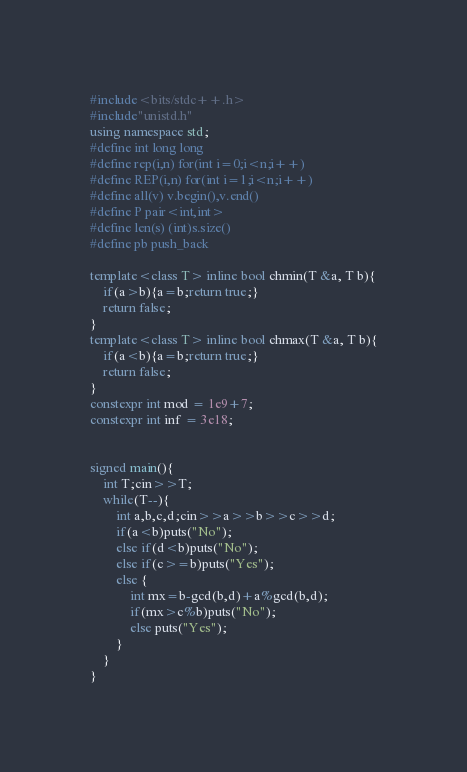Convert code to text. <code><loc_0><loc_0><loc_500><loc_500><_C++_>#include<bits/stdc++.h>
#include"unistd.h"
using namespace std;
#define int long long
#define rep(i,n) for(int i=0;i<n;i++)
#define REP(i,n) for(int i=1;i<n;i++)
#define all(v) v.begin(),v.end()
#define P pair<int,int>
#define len(s) (int)s.size()
#define pb push_back

template<class T> inline bool chmin(T &a, T b){
	if(a>b){a=b;return true;}
	return false;
}
template<class T> inline bool chmax(T &a, T b){
	if(a<b){a=b;return true;}
	return false;
}
constexpr int mod = 1e9+7;
constexpr int inf = 3e18;


signed main(){
	int T;cin>>T;
	while(T--){
		int a,b,c,d;cin>>a>>b>>c>>d;
		if(a<b)puts("No");
		else if(d<b)puts("No");
		else if(c>=b)puts("Yes");
		else {
			int mx=b-gcd(b,d)+a%gcd(b,d);
			if(mx>c%b)puts("No");
			else puts("Yes");
		}
	}
}
</code> 